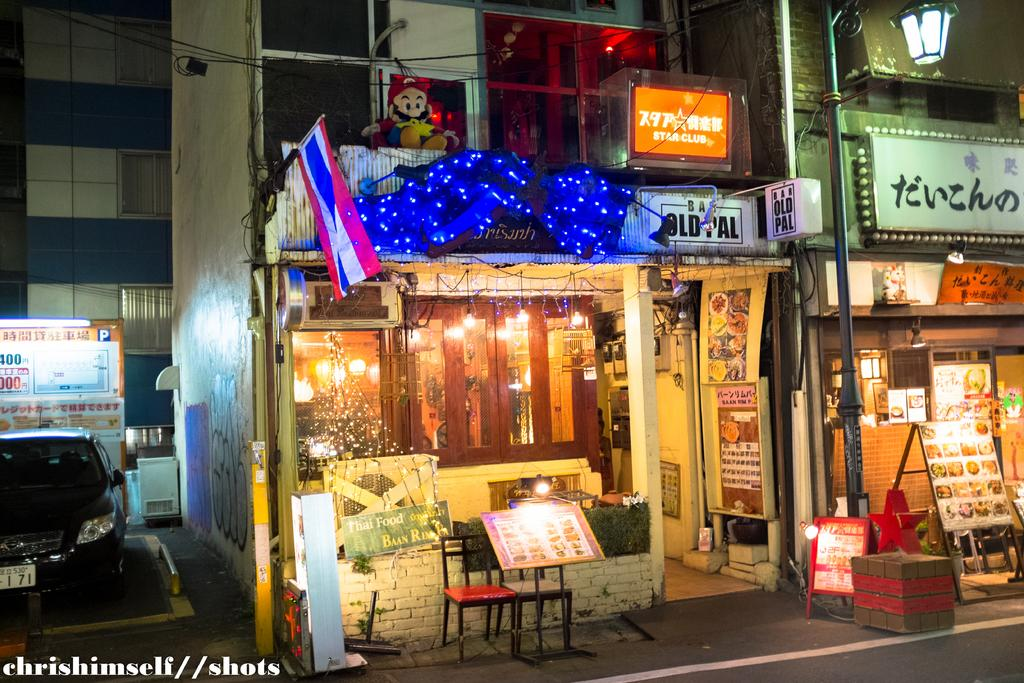What can be seen flying in the image? There is a flag in the image. What is present in a shop in the image in the image? There are lights in a shop in the image. What type of outdoor lighting is visible in the image? There is a streetlight in the image. What type of furniture is present in the image? There is a chair in the image. What mode of transportation is visible in the image? There is a car in the image. What type of signage is present in the image? There is a board in the image. What type of container is present in the image? There is a box in the image. What type of beverage container is present in the image? There is a bottle in the image. Can you tell me how many giraffes are standing near the car in the image? There are no giraffes present in the image. What type of adjustment can be seen being made to the streetlight in the image? There is no adjustment being made to the streetlight in the image; it is stationary. What type of vegetable is present in the image? There are no vegetables present in the image. 